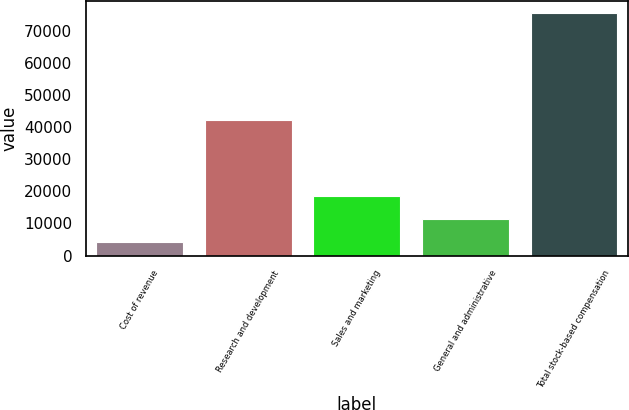Convert chart to OTSL. <chart><loc_0><loc_0><loc_500><loc_500><bar_chart><fcel>Cost of revenue<fcel>Research and development<fcel>Sales and marketing<fcel>General and administrative<fcel>Total stock-based compensation<nl><fcel>4353<fcel>42184<fcel>18567.8<fcel>11460.4<fcel>75427<nl></chart> 